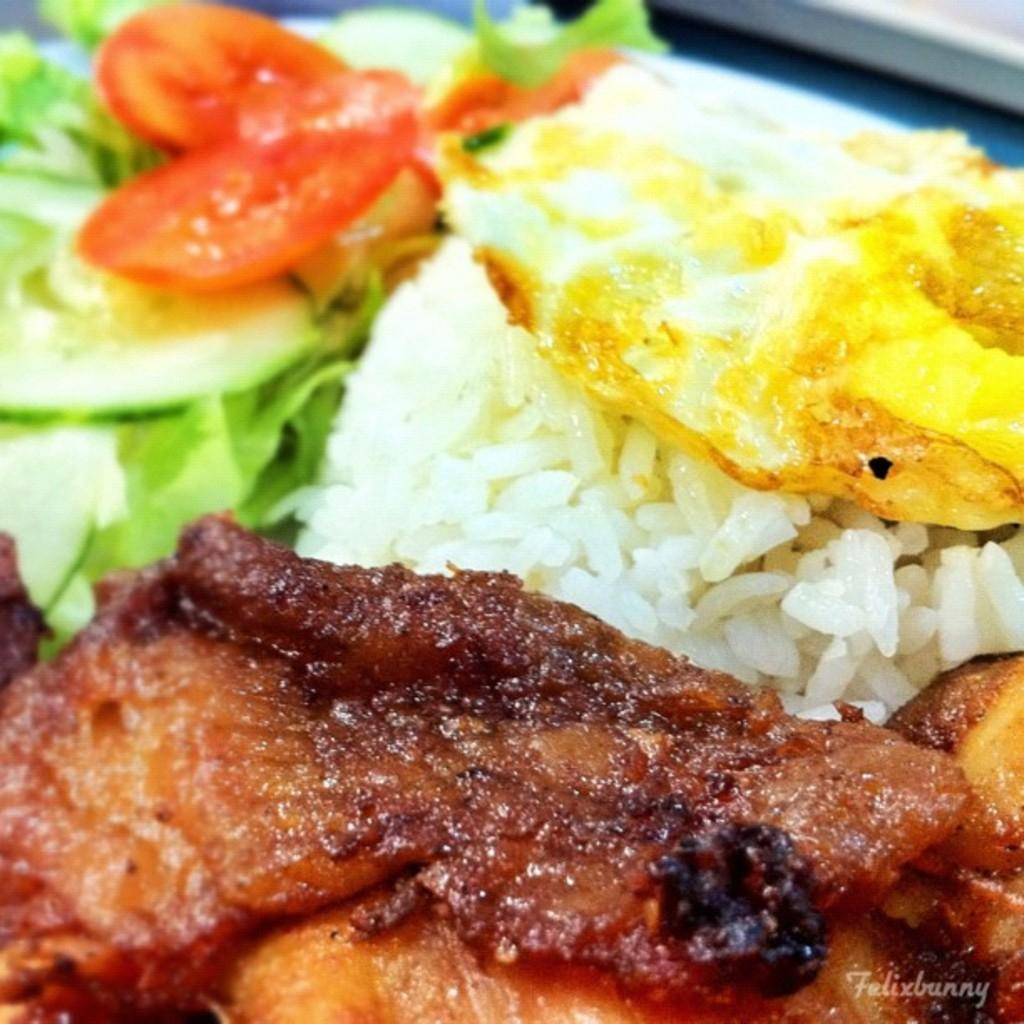What colors can be seen in the food in the image? There is food in brown, white, yellow, red, and green colors in the image. Can you describe the variety of colors present in the food? The food in the image features a mix of warm and cool colors, including brown, white, yellow, red, and green. Where are the dolls located in the image? There are no dolls present in the image. Can you describe the cave in the image? There is no cave present in the image. 